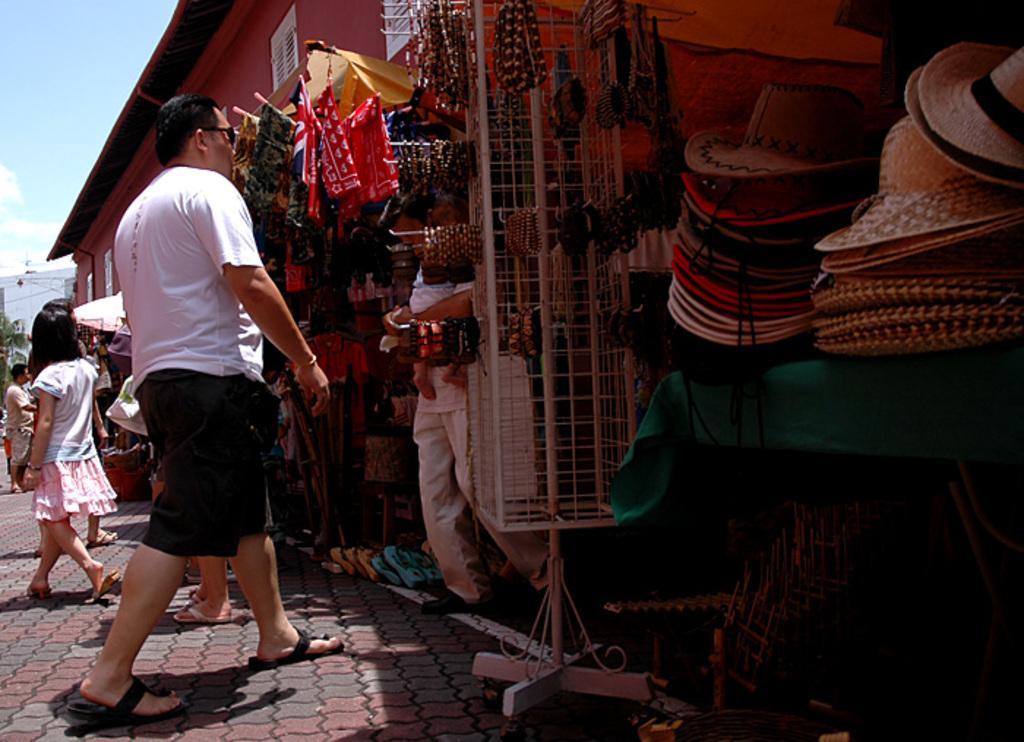Please provide a concise description of this image. In this image I can see a crowd and shops. On the top left I can see the sky. This image is taken during a day on the street. 